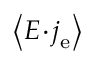<formula> <loc_0><loc_0><loc_500><loc_500>\left < E \, \cdot \, j _ { e } \right ></formula> 